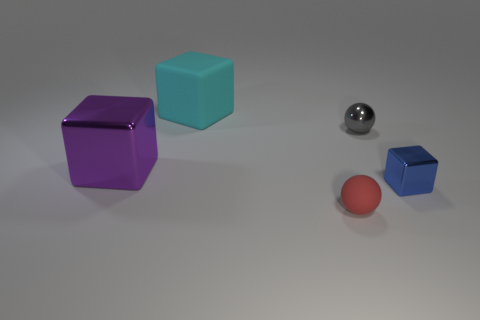There is a big object to the right of the purple block; what is it made of?
Provide a succinct answer. Rubber. There is another metallic thing that is the same shape as the blue metallic thing; what size is it?
Offer a terse response. Large. Are there fewer balls behind the cyan matte object than small matte cubes?
Your answer should be very brief. No. Is there a large purple metallic sphere?
Offer a terse response. No. The other thing that is the same shape as the gray metallic object is what color?
Offer a very short reply. Red. Do the red matte sphere and the gray object have the same size?
Give a very brief answer. Yes. What shape is the small object that is the same material as the tiny gray ball?
Ensure brevity in your answer.  Cube. What number of other things are the same shape as the tiny red rubber thing?
Keep it short and to the point. 1. There is a thing in front of the small shiny thing that is in front of the big object that is in front of the cyan object; what is its shape?
Ensure brevity in your answer.  Sphere. How many blocks are either cyan rubber things or big purple things?
Give a very brief answer. 2. 